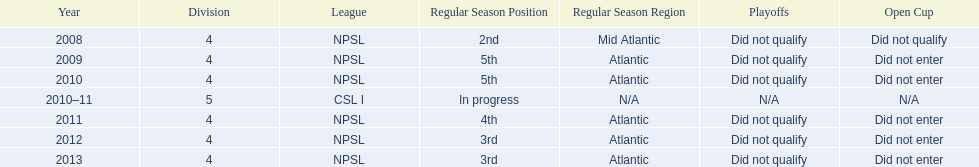Which year was more successful, 2010 or 2013? 2013. 